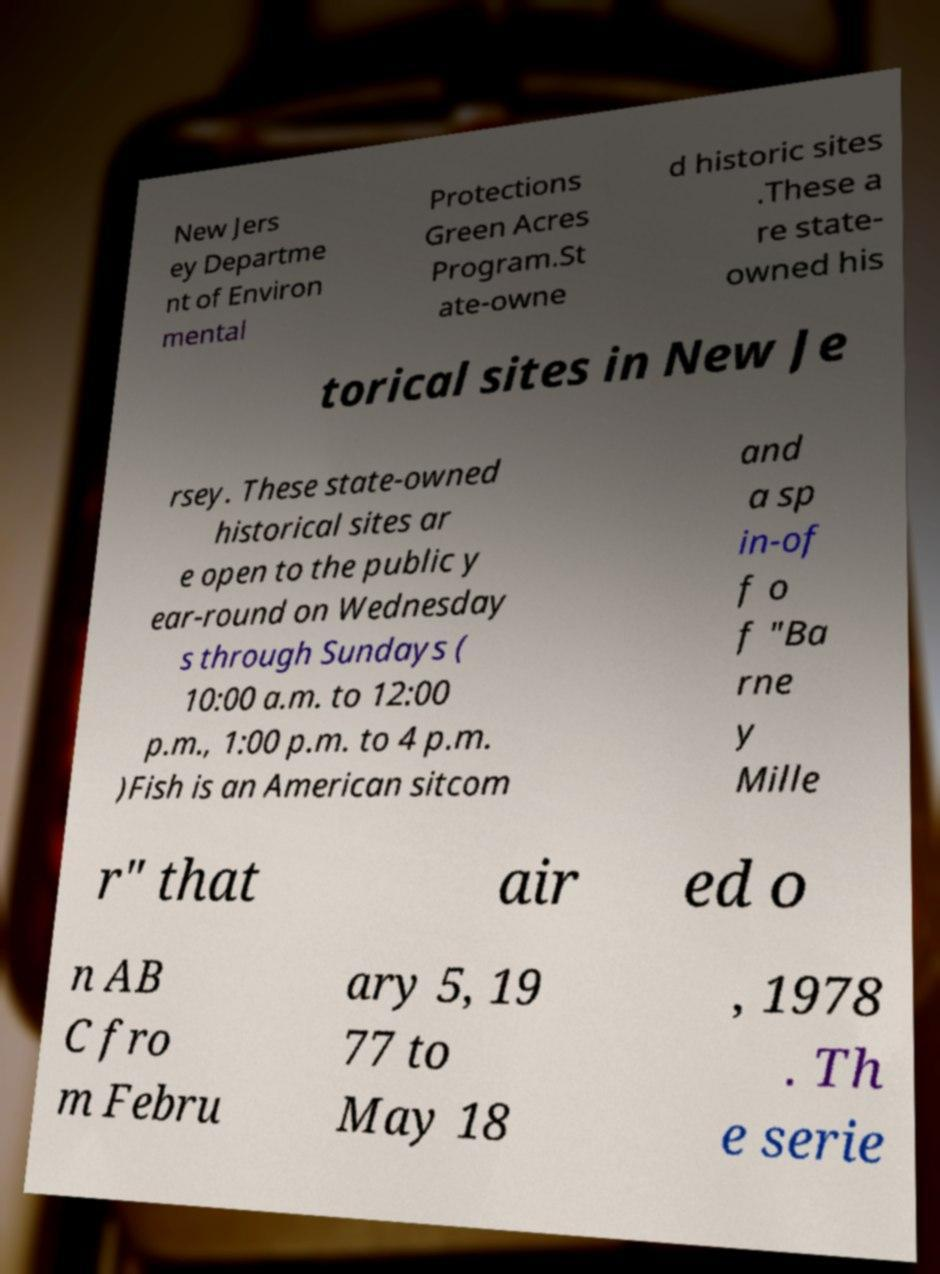What messages or text are displayed in this image? I need them in a readable, typed format. New Jers ey Departme nt of Environ mental Protections Green Acres Program.St ate-owne d historic sites .These a re state- owned his torical sites in New Je rsey. These state-owned historical sites ar e open to the public y ear-round on Wednesday s through Sundays ( 10:00 a.m. to 12:00 p.m., 1:00 p.m. to 4 p.m. )Fish is an American sitcom and a sp in-of f o f "Ba rne y Mille r" that air ed o n AB C fro m Febru ary 5, 19 77 to May 18 , 1978 . Th e serie 